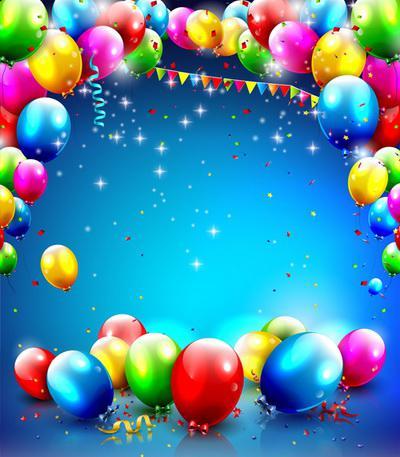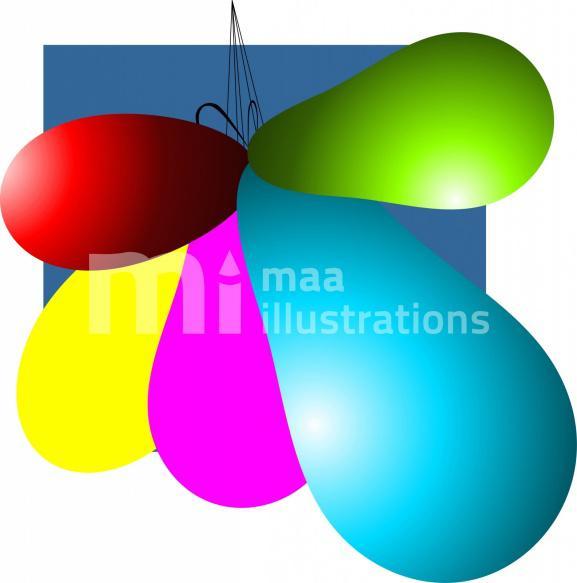The first image is the image on the left, the second image is the image on the right. Considering the images on both sides, is "In at least one image there are eight balloon with strings on them." valid? Answer yes or no. No. 